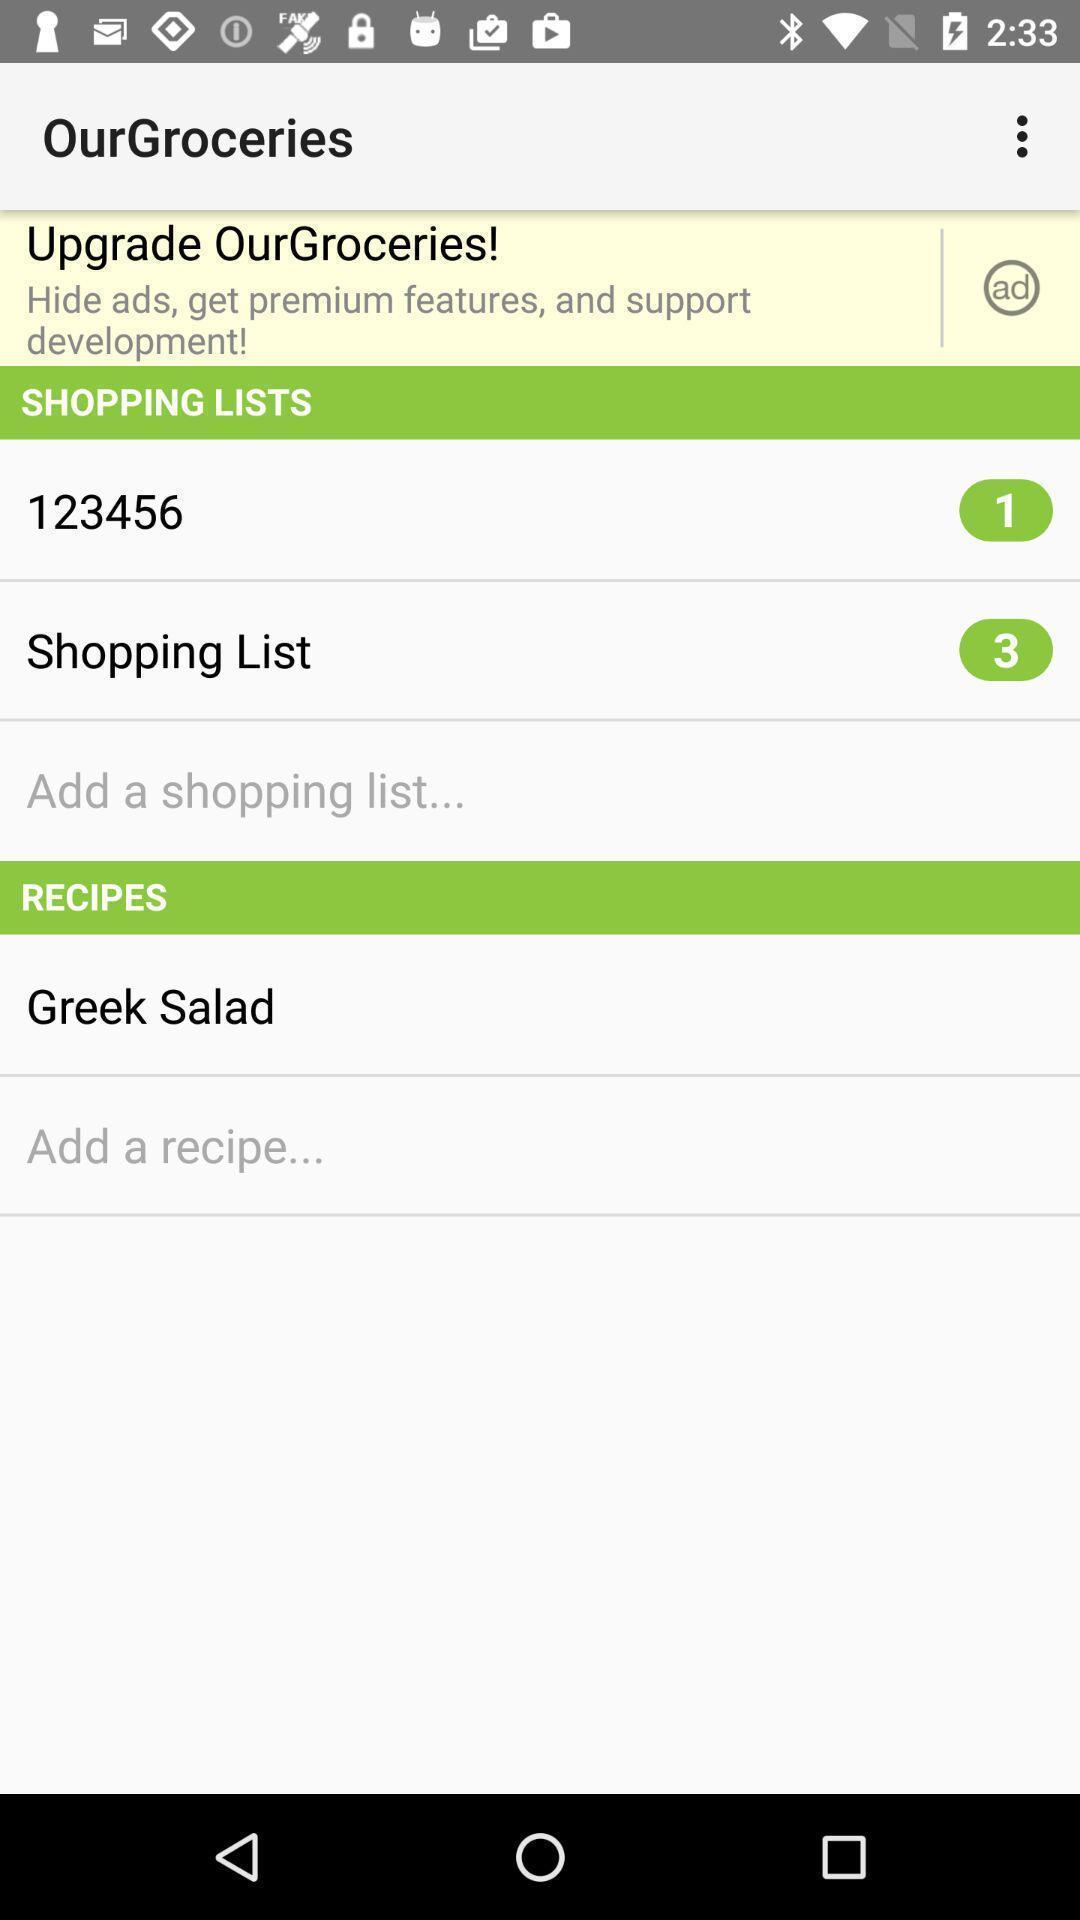What details can you identify in this image? Various categories in a grocery app. 